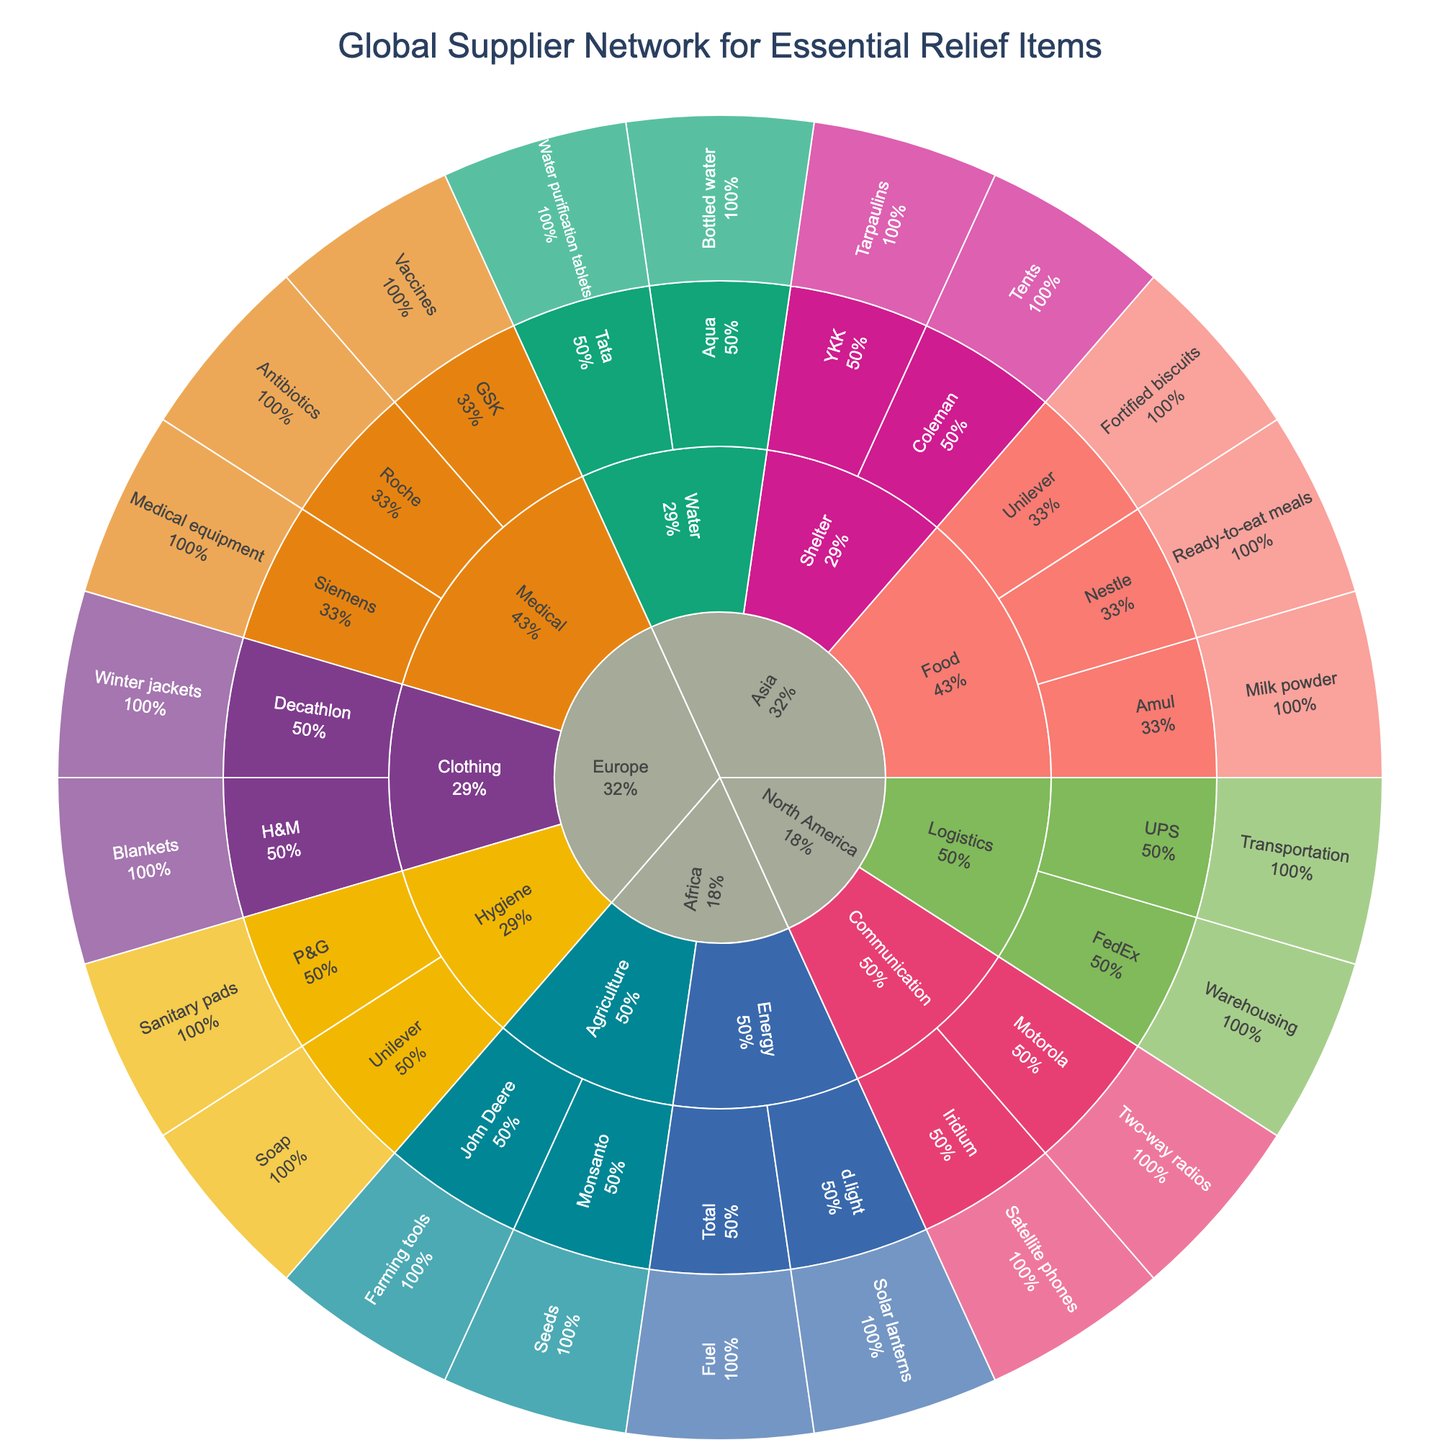What is the title of the sunburst plot? The title is prominently displayed at the top of the figure and provides an overview of what the plot represents.
Answer: Global Supplier Network for Essential Relief Items Which region has the highest number of categories for essential relief items? The outermost ring shows categories for each region. Identify the region with the most sectors in the ring.
Answer: Asia How many suppliers are listed under the 'Medical' category in Europe? Follow the hierarchy from the 'Europe' region to the 'Medical' category and count the number of suppliers listed.
Answer: 3 What product does 'Iridium' supply in North America? Trace the path starting from the 'North America' region to the 'Communication' category and identify the product listed under 'Iridium'.
Answer: Satellite phones Compare the number of food suppliers in Asia to the number of hygiene suppliers in Europe. Which is greater? Count the suppliers under the 'Food' category in Asia. Similarly, count the suppliers under the 'Hygiene' category in Europe, then compare the two numbers.
Answer: Food suppliers in Asia What percentage of suppliers fall under the 'Logistics' category in North America? Find the percentage labeled on the 'Logistics' category segment under North America. This shows the proportion of the total suppliers that belong to this category.
Answer: 50% Which region has suppliers offering 'Water purification tablets'? Follow the hierarchy path from the root to 'Water' and find the specific region associated with 'Water purification tablets'.
Answer: Asia List all products supplied by companies in the 'Energy' category in Africa. Navigate from the 'Africa' region to the 'Energy' category and list the products associated with the suppliers in this segment.
Answer: Fuel, Solar lanterns Which category has the smallest number of suppliers listed under it in Europe? Identify all categories under 'Europe' and compare the counts of suppliers in each category to determine the smallest.
Answer: Clothing What is the total number of suppliers in the 'Agriculture' category across all regions? Sum the number of suppliers listed under the 'Agriculture' category for each region. This involves counting each region's 'Agriculture' suppliers and adding them together.
Answer: 2 